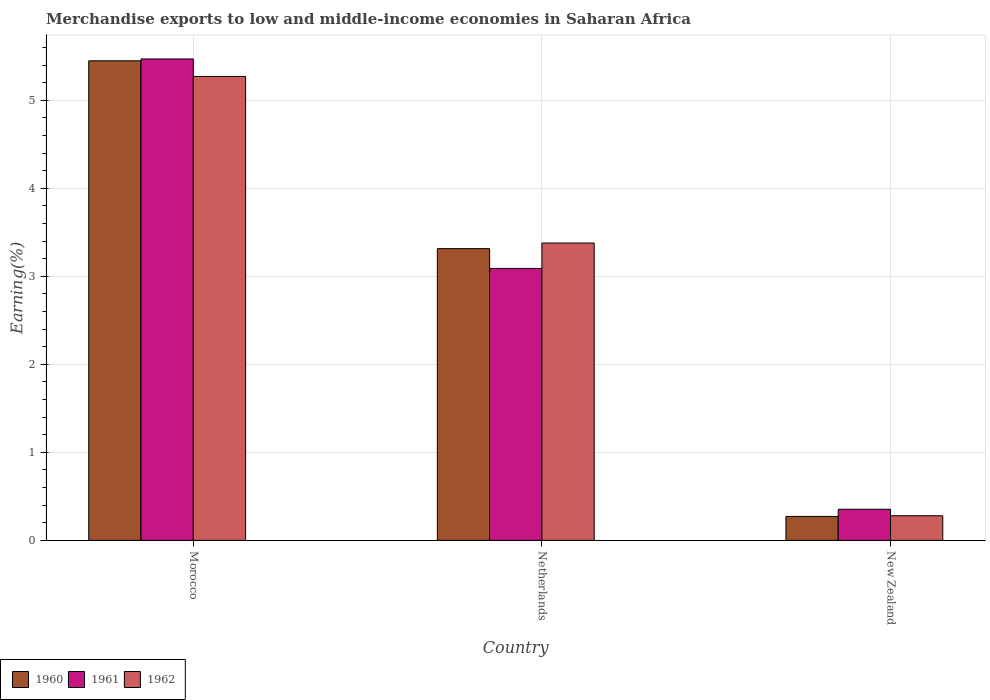How many groups of bars are there?
Provide a short and direct response. 3. Are the number of bars per tick equal to the number of legend labels?
Your response must be concise. Yes. How many bars are there on the 2nd tick from the left?
Offer a terse response. 3. How many bars are there on the 2nd tick from the right?
Your response must be concise. 3. What is the label of the 1st group of bars from the left?
Provide a short and direct response. Morocco. In how many cases, is the number of bars for a given country not equal to the number of legend labels?
Provide a succinct answer. 0. What is the percentage of amount earned from merchandise exports in 1961 in Morocco?
Your answer should be compact. 5.47. Across all countries, what is the maximum percentage of amount earned from merchandise exports in 1961?
Your answer should be very brief. 5.47. Across all countries, what is the minimum percentage of amount earned from merchandise exports in 1961?
Ensure brevity in your answer.  0.35. In which country was the percentage of amount earned from merchandise exports in 1961 maximum?
Your answer should be very brief. Morocco. In which country was the percentage of amount earned from merchandise exports in 1962 minimum?
Provide a succinct answer. New Zealand. What is the total percentage of amount earned from merchandise exports in 1962 in the graph?
Provide a short and direct response. 8.93. What is the difference between the percentage of amount earned from merchandise exports in 1960 in Netherlands and that in New Zealand?
Provide a short and direct response. 3.04. What is the difference between the percentage of amount earned from merchandise exports in 1961 in New Zealand and the percentage of amount earned from merchandise exports in 1962 in Morocco?
Your answer should be very brief. -4.92. What is the average percentage of amount earned from merchandise exports in 1960 per country?
Offer a terse response. 3.01. What is the difference between the percentage of amount earned from merchandise exports of/in 1960 and percentage of amount earned from merchandise exports of/in 1962 in Morocco?
Your answer should be compact. 0.18. What is the ratio of the percentage of amount earned from merchandise exports in 1962 in Morocco to that in Netherlands?
Your response must be concise. 1.56. What is the difference between the highest and the second highest percentage of amount earned from merchandise exports in 1960?
Provide a succinct answer. -3.04. What is the difference between the highest and the lowest percentage of amount earned from merchandise exports in 1961?
Keep it short and to the point. 5.12. What does the 1st bar from the left in Netherlands represents?
Give a very brief answer. 1960. What does the 1st bar from the right in New Zealand represents?
Provide a succinct answer. 1962. Are all the bars in the graph horizontal?
Offer a terse response. No. How many countries are there in the graph?
Your answer should be very brief. 3. What is the difference between two consecutive major ticks on the Y-axis?
Provide a short and direct response. 1. Are the values on the major ticks of Y-axis written in scientific E-notation?
Ensure brevity in your answer.  No. What is the title of the graph?
Keep it short and to the point. Merchandise exports to low and middle-income economies in Saharan Africa. Does "1974" appear as one of the legend labels in the graph?
Your answer should be compact. No. What is the label or title of the Y-axis?
Your answer should be compact. Earning(%). What is the Earning(%) of 1960 in Morocco?
Keep it short and to the point. 5.45. What is the Earning(%) of 1961 in Morocco?
Offer a very short reply. 5.47. What is the Earning(%) in 1962 in Morocco?
Offer a terse response. 5.27. What is the Earning(%) in 1960 in Netherlands?
Your answer should be very brief. 3.31. What is the Earning(%) in 1961 in Netherlands?
Your response must be concise. 3.09. What is the Earning(%) of 1962 in Netherlands?
Offer a terse response. 3.38. What is the Earning(%) in 1960 in New Zealand?
Make the answer very short. 0.27. What is the Earning(%) in 1961 in New Zealand?
Ensure brevity in your answer.  0.35. What is the Earning(%) of 1962 in New Zealand?
Ensure brevity in your answer.  0.28. Across all countries, what is the maximum Earning(%) of 1960?
Your answer should be very brief. 5.45. Across all countries, what is the maximum Earning(%) of 1961?
Provide a short and direct response. 5.47. Across all countries, what is the maximum Earning(%) in 1962?
Your response must be concise. 5.27. Across all countries, what is the minimum Earning(%) of 1960?
Keep it short and to the point. 0.27. Across all countries, what is the minimum Earning(%) of 1961?
Offer a very short reply. 0.35. Across all countries, what is the minimum Earning(%) of 1962?
Offer a very short reply. 0.28. What is the total Earning(%) in 1960 in the graph?
Your response must be concise. 9.04. What is the total Earning(%) in 1961 in the graph?
Your response must be concise. 8.91. What is the total Earning(%) in 1962 in the graph?
Make the answer very short. 8.93. What is the difference between the Earning(%) in 1960 in Morocco and that in Netherlands?
Ensure brevity in your answer.  2.13. What is the difference between the Earning(%) of 1961 in Morocco and that in Netherlands?
Provide a short and direct response. 2.38. What is the difference between the Earning(%) in 1962 in Morocco and that in Netherlands?
Give a very brief answer. 1.89. What is the difference between the Earning(%) of 1960 in Morocco and that in New Zealand?
Your answer should be very brief. 5.18. What is the difference between the Earning(%) of 1961 in Morocco and that in New Zealand?
Your answer should be compact. 5.12. What is the difference between the Earning(%) of 1962 in Morocco and that in New Zealand?
Your answer should be compact. 4.99. What is the difference between the Earning(%) in 1960 in Netherlands and that in New Zealand?
Keep it short and to the point. 3.04. What is the difference between the Earning(%) in 1961 in Netherlands and that in New Zealand?
Your response must be concise. 2.74. What is the difference between the Earning(%) of 1962 in Netherlands and that in New Zealand?
Your answer should be very brief. 3.1. What is the difference between the Earning(%) in 1960 in Morocco and the Earning(%) in 1961 in Netherlands?
Offer a terse response. 2.36. What is the difference between the Earning(%) in 1960 in Morocco and the Earning(%) in 1962 in Netherlands?
Provide a succinct answer. 2.07. What is the difference between the Earning(%) in 1961 in Morocco and the Earning(%) in 1962 in Netherlands?
Provide a short and direct response. 2.09. What is the difference between the Earning(%) of 1960 in Morocco and the Earning(%) of 1961 in New Zealand?
Make the answer very short. 5.09. What is the difference between the Earning(%) of 1960 in Morocco and the Earning(%) of 1962 in New Zealand?
Offer a terse response. 5.17. What is the difference between the Earning(%) in 1961 in Morocco and the Earning(%) in 1962 in New Zealand?
Your response must be concise. 5.19. What is the difference between the Earning(%) of 1960 in Netherlands and the Earning(%) of 1961 in New Zealand?
Provide a short and direct response. 2.96. What is the difference between the Earning(%) of 1960 in Netherlands and the Earning(%) of 1962 in New Zealand?
Offer a terse response. 3.03. What is the difference between the Earning(%) in 1961 in Netherlands and the Earning(%) in 1962 in New Zealand?
Your response must be concise. 2.81. What is the average Earning(%) in 1960 per country?
Your answer should be compact. 3.01. What is the average Earning(%) of 1961 per country?
Offer a terse response. 2.97. What is the average Earning(%) in 1962 per country?
Provide a succinct answer. 2.98. What is the difference between the Earning(%) of 1960 and Earning(%) of 1961 in Morocco?
Your answer should be compact. -0.02. What is the difference between the Earning(%) of 1960 and Earning(%) of 1962 in Morocco?
Ensure brevity in your answer.  0.18. What is the difference between the Earning(%) of 1961 and Earning(%) of 1962 in Morocco?
Your response must be concise. 0.2. What is the difference between the Earning(%) of 1960 and Earning(%) of 1961 in Netherlands?
Provide a short and direct response. 0.23. What is the difference between the Earning(%) of 1960 and Earning(%) of 1962 in Netherlands?
Provide a succinct answer. -0.06. What is the difference between the Earning(%) of 1961 and Earning(%) of 1962 in Netherlands?
Provide a succinct answer. -0.29. What is the difference between the Earning(%) of 1960 and Earning(%) of 1961 in New Zealand?
Ensure brevity in your answer.  -0.08. What is the difference between the Earning(%) of 1960 and Earning(%) of 1962 in New Zealand?
Your answer should be compact. -0.01. What is the difference between the Earning(%) in 1961 and Earning(%) in 1962 in New Zealand?
Your answer should be compact. 0.07. What is the ratio of the Earning(%) in 1960 in Morocco to that in Netherlands?
Ensure brevity in your answer.  1.64. What is the ratio of the Earning(%) of 1961 in Morocco to that in Netherlands?
Give a very brief answer. 1.77. What is the ratio of the Earning(%) of 1962 in Morocco to that in Netherlands?
Your answer should be very brief. 1.56. What is the ratio of the Earning(%) of 1960 in Morocco to that in New Zealand?
Ensure brevity in your answer.  20.01. What is the ratio of the Earning(%) in 1961 in Morocco to that in New Zealand?
Your answer should be compact. 15.46. What is the ratio of the Earning(%) of 1962 in Morocco to that in New Zealand?
Your response must be concise. 18.83. What is the ratio of the Earning(%) of 1960 in Netherlands to that in New Zealand?
Provide a short and direct response. 12.18. What is the ratio of the Earning(%) of 1961 in Netherlands to that in New Zealand?
Your answer should be very brief. 8.73. What is the ratio of the Earning(%) in 1962 in Netherlands to that in New Zealand?
Your response must be concise. 12.07. What is the difference between the highest and the second highest Earning(%) of 1960?
Offer a terse response. 2.13. What is the difference between the highest and the second highest Earning(%) of 1961?
Provide a short and direct response. 2.38. What is the difference between the highest and the second highest Earning(%) in 1962?
Make the answer very short. 1.89. What is the difference between the highest and the lowest Earning(%) in 1960?
Make the answer very short. 5.18. What is the difference between the highest and the lowest Earning(%) in 1961?
Provide a short and direct response. 5.12. What is the difference between the highest and the lowest Earning(%) in 1962?
Your response must be concise. 4.99. 